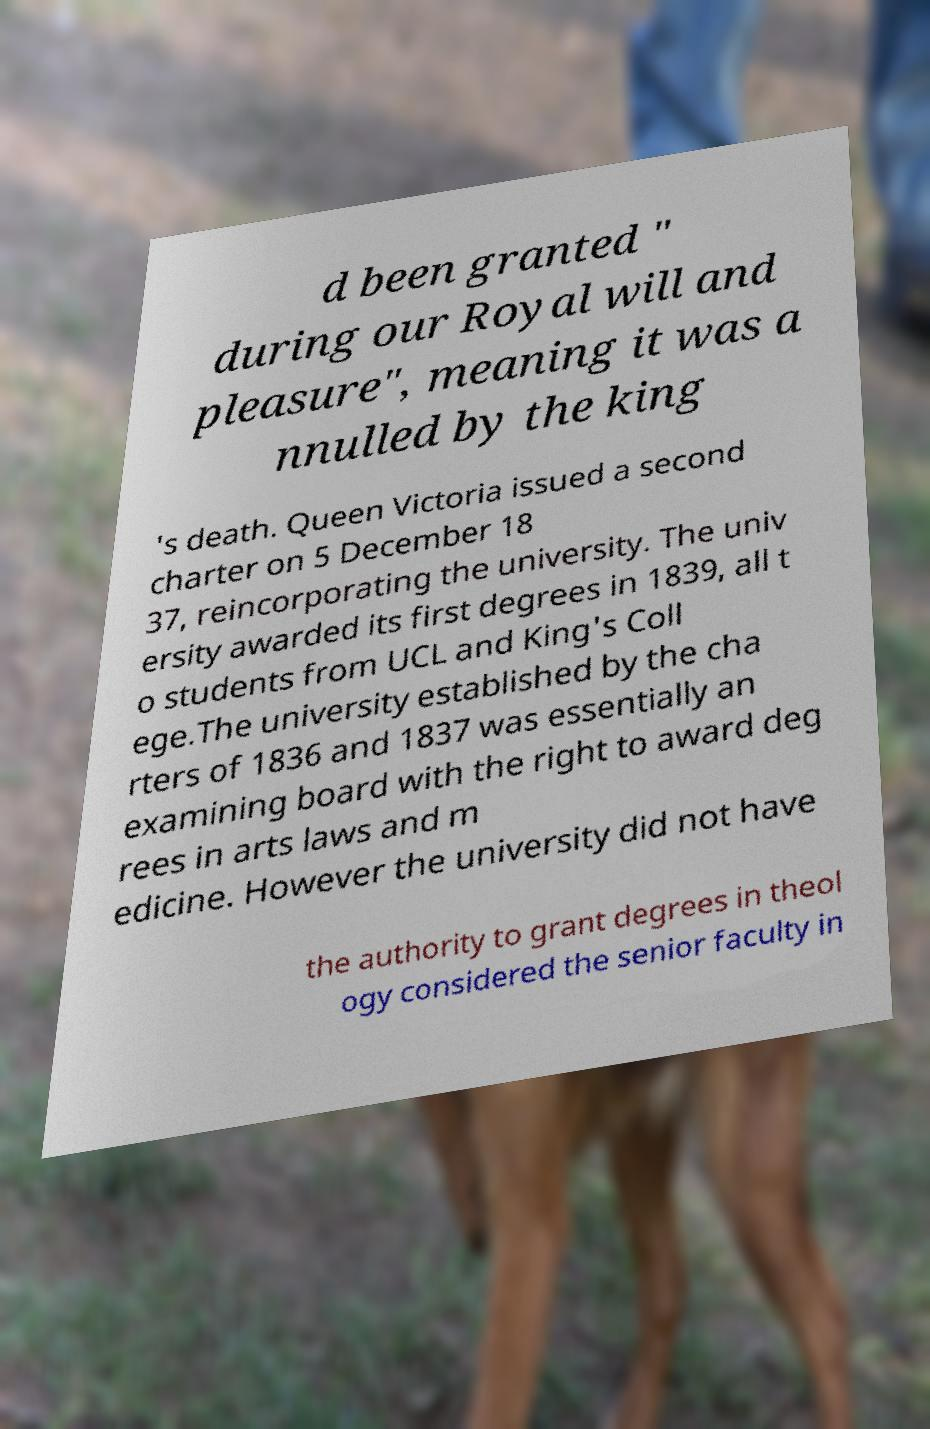I need the written content from this picture converted into text. Can you do that? d been granted " during our Royal will and pleasure", meaning it was a nnulled by the king 's death. Queen Victoria issued a second charter on 5 December 18 37, reincorporating the university. The univ ersity awarded its first degrees in 1839, all t o students from UCL and King's Coll ege.The university established by the cha rters of 1836 and 1837 was essentially an examining board with the right to award deg rees in arts laws and m edicine. However the university did not have the authority to grant degrees in theol ogy considered the senior faculty in 